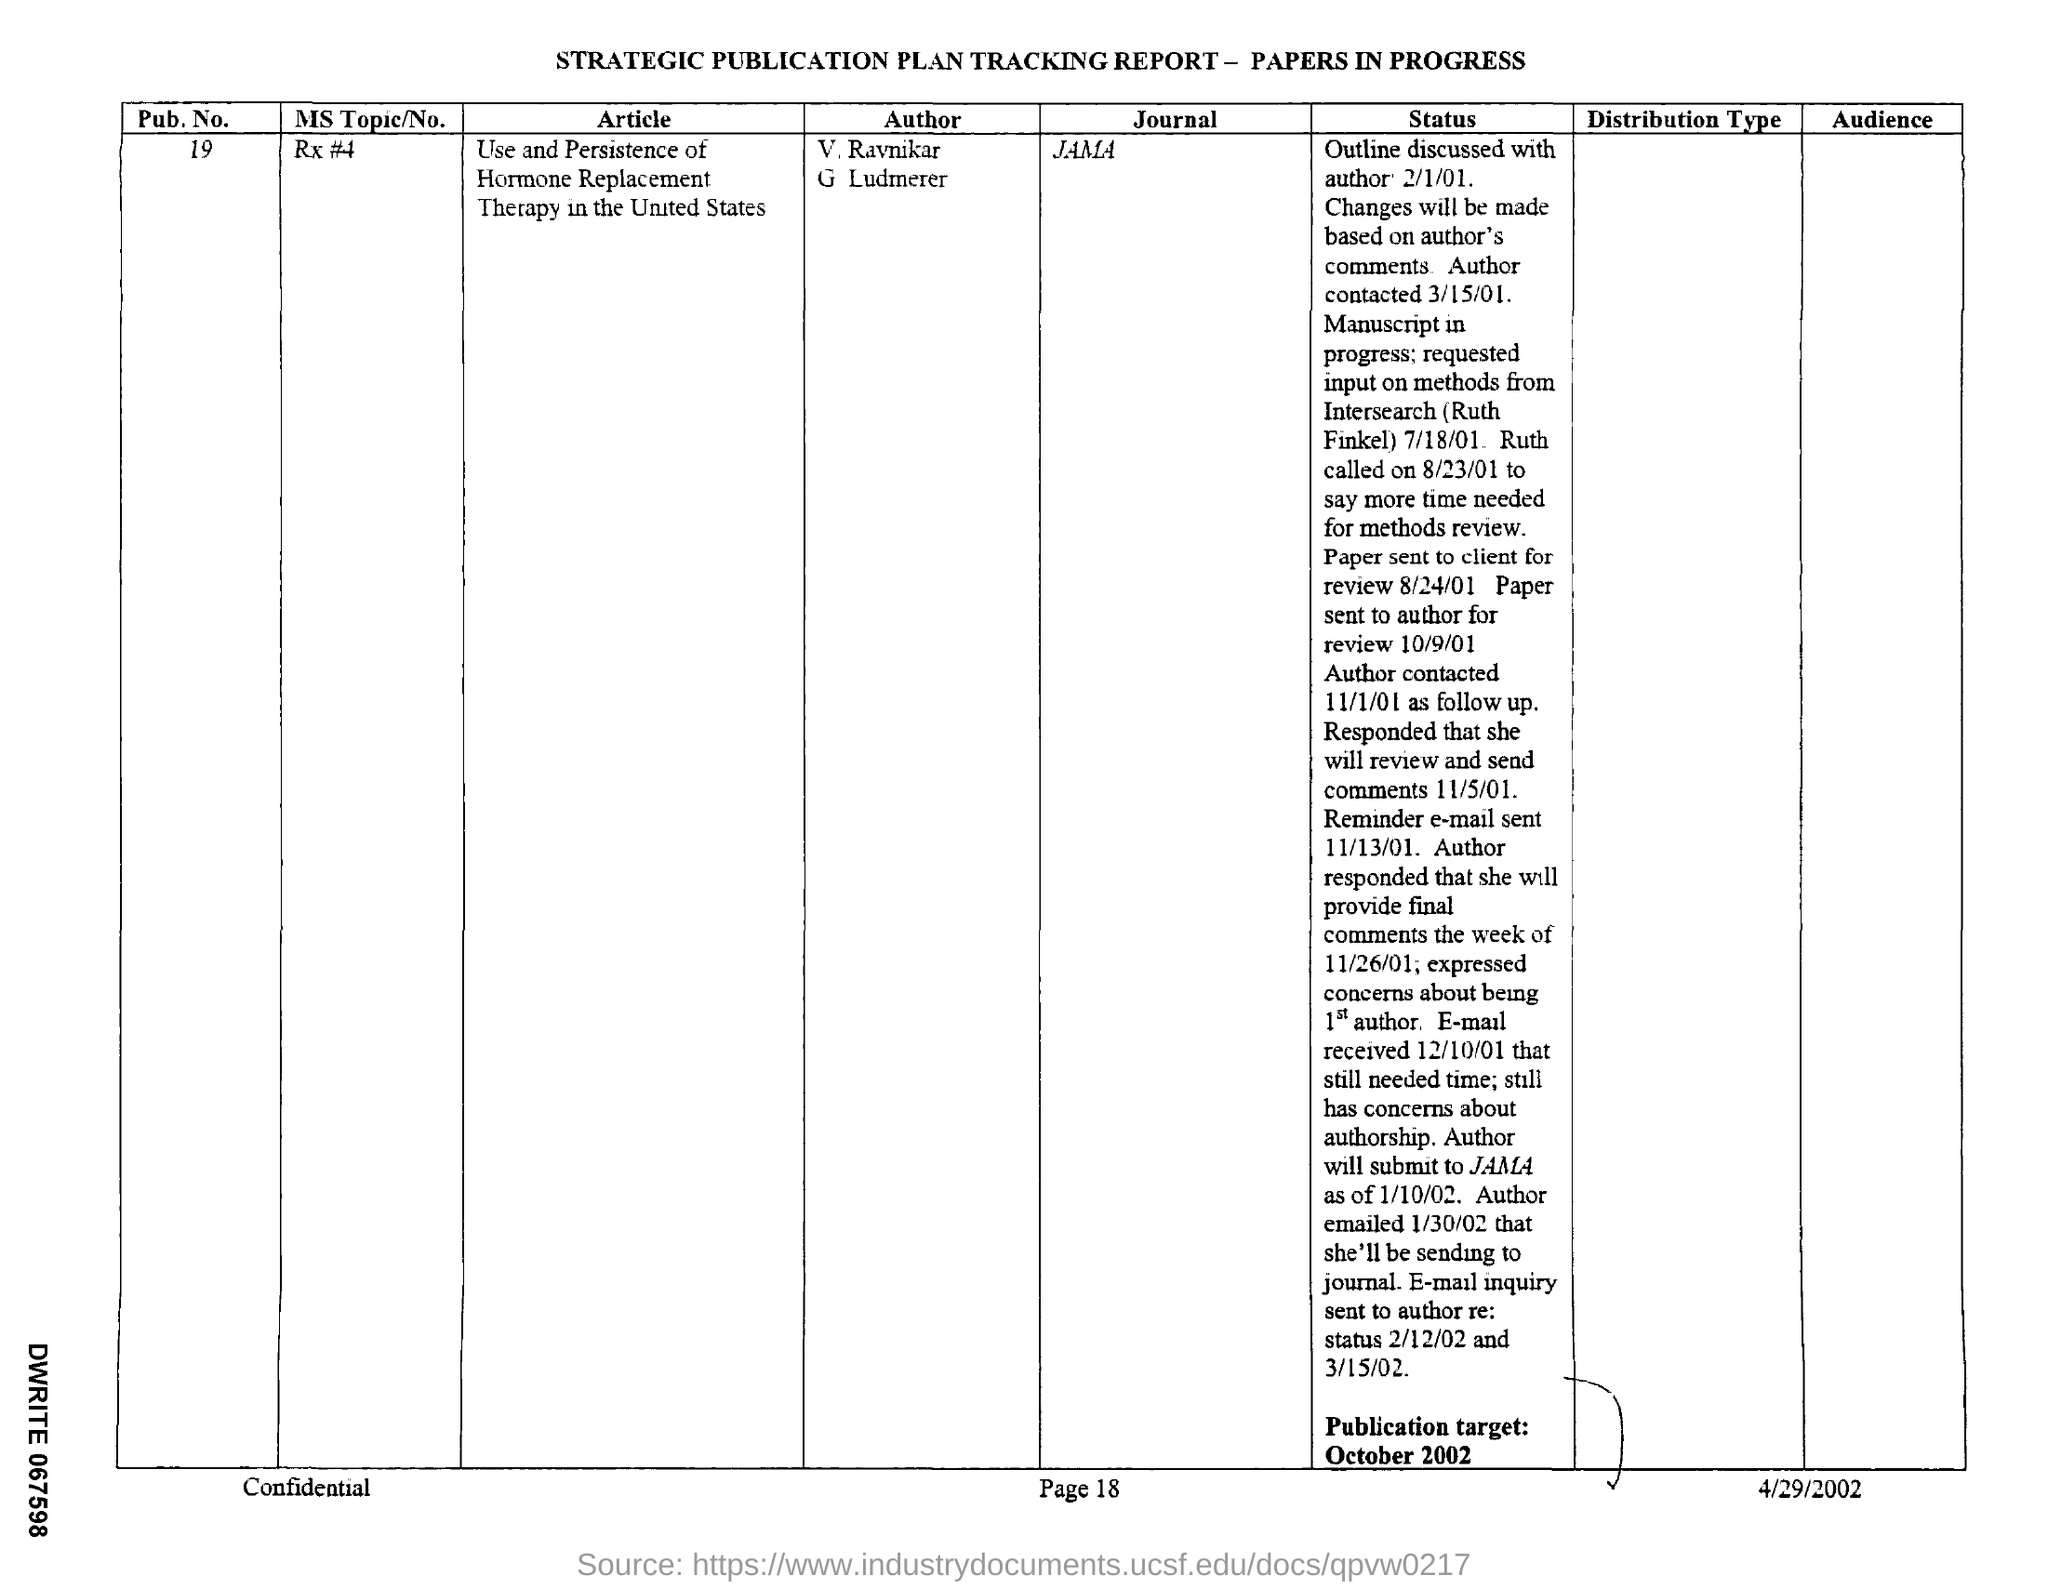Indicate a few pertinent items in this graphic. On what date was the reminder e-mail sent? The reminder e-mail was sent on 11/13/01. The request is asking for information regarding the Publication Number, which is 19... The date on which the paper was sent to the author for review is 10/09/01. On the date of November 1, 2001, the author contacted the person for follow-up. The journal name mentioned is JAMA. 